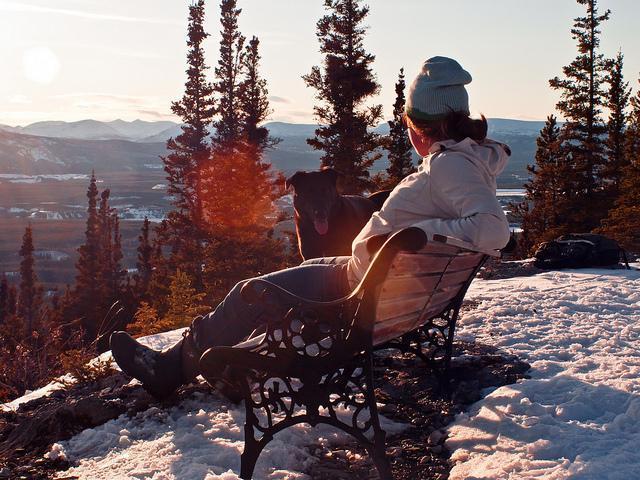How many dogs are there?
Give a very brief answer. 1. 